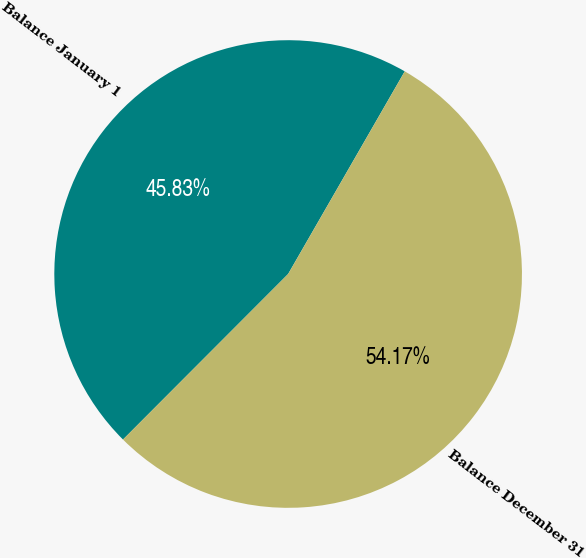Convert chart. <chart><loc_0><loc_0><loc_500><loc_500><pie_chart><fcel>Balance January 1<fcel>Balance December 31<nl><fcel>45.83%<fcel>54.17%<nl></chart> 